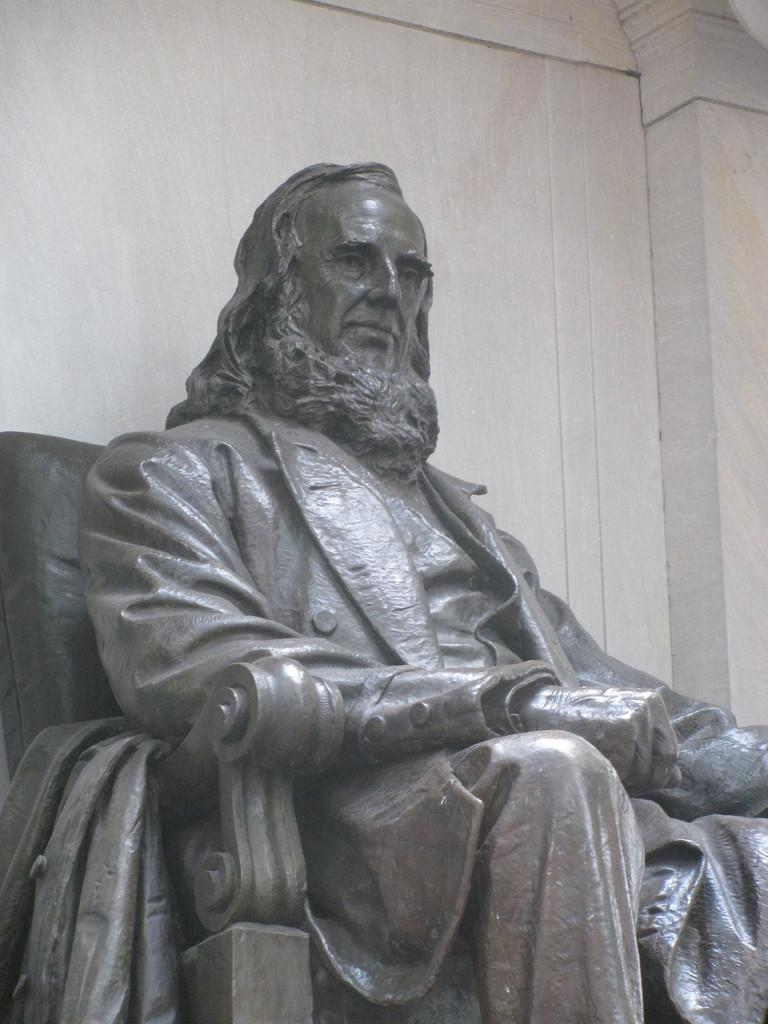What is the main subject in the image? There is a statue in the image. What else can be seen in the image besides the statue? There is a wall in the image. What type of current can be seen flowing around the statue in the image? There is no current visible in the image; it only features a statue and a wall. What type of coach is present in the image? There is no coach present in the image. 